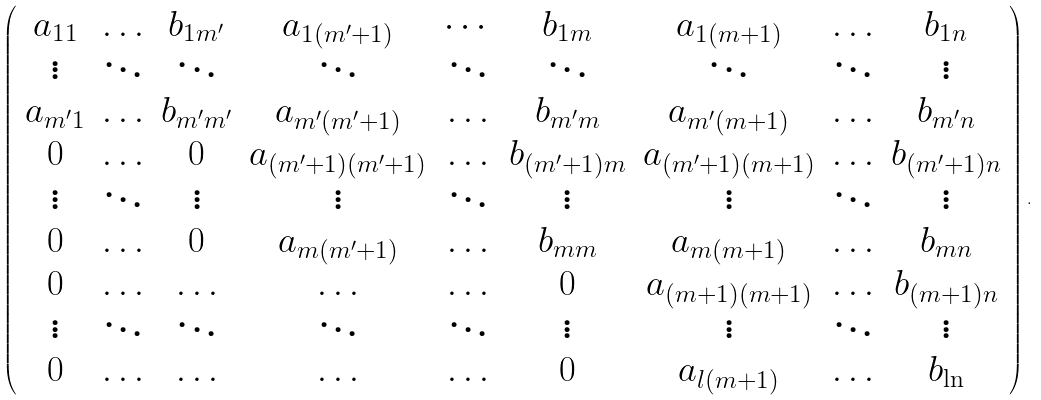<formula> <loc_0><loc_0><loc_500><loc_500>\left ( \begin{array} { c c c c c c c c c } a _ { 1 1 } & \hdots & b _ { 1 m ^ { \prime } } & a _ { 1 ( m ^ { \prime } + 1 ) } & \cdots & b _ { 1 m } & a _ { 1 ( m + 1 ) } & \hdots & b _ { 1 n } \\ \vdots & \ddots & \ddots & \ddots & \ddots & \ddots & \ddots & \ddots & \vdots \\ a _ { m ^ { \prime } 1 } & \hdots & b _ { m ^ { \prime } m ^ { \prime } } & a _ { m ^ { \prime } ( m ^ { \prime } + 1 ) } & \hdots & b _ { m ^ { \prime } m } & a _ { m ^ { \prime } ( m + 1 ) } & \hdots & b _ { m ^ { \prime } n } \\ 0 & \hdots & 0 & a _ { ( m ^ { \prime } + 1 ) ( m ^ { \prime } + 1 ) } & \hdots & b _ { ( m ^ { \prime } + 1 ) m } & a _ { ( m ^ { \prime } + 1 ) ( m + 1 ) } & \hdots & b _ { ( m ^ { \prime } + 1 ) n } \\ \vdots & \ddots & \vdots & \vdots & \ddots & \vdots & \vdots & \ddots & \vdots \\ 0 & \hdots & 0 & a _ { m ( m ^ { \prime } + 1 ) } & \hdots & b _ { m m } & a _ { m ( m + 1 ) } & \hdots & b _ { m n } \\ 0 & \hdots & \hdots & \hdots & \hdots & 0 & a _ { ( m + 1 ) ( m + 1 ) } & \hdots & b _ { ( m + 1 ) n } \\ \vdots & \ddots & \ddots & \ddots & \ddots & \vdots & \vdots & \ddots & \vdots \\ 0 & \hdots & \hdots & \hdots & \hdots & 0 & a _ { l ( m + 1 ) } & \hdots & b _ { \ln } \end{array} \right ) .</formula> 